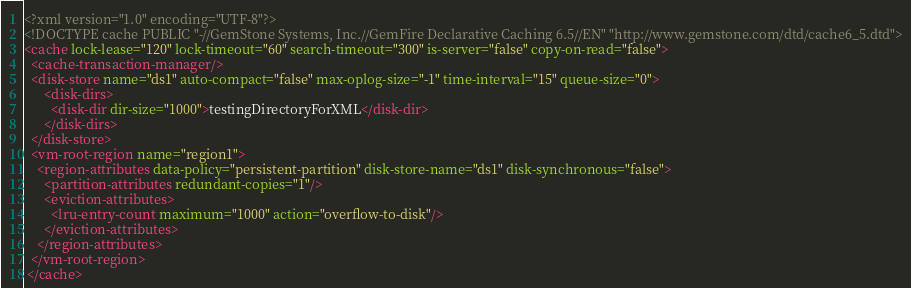Convert code to text. <code><loc_0><loc_0><loc_500><loc_500><_XML_><?xml version="1.0" encoding="UTF-8"?>
<!DOCTYPE cache PUBLIC "-//GemStone Systems, Inc.//GemFire Declarative Caching 6.5//EN" "http://www.gemstone.com/dtd/cache6_5.dtd">
<cache lock-lease="120" lock-timeout="60" search-timeout="300" is-server="false" copy-on-read="false">
  <cache-transaction-manager/>
  <disk-store name="ds1" auto-compact="false" max-oplog-size="-1" time-interval="15" queue-size="0">
      <disk-dirs>
        <disk-dir dir-size="1000">testingDirectoryForXML</disk-dir>
      </disk-dirs>
  </disk-store>
  <vm-root-region name="region1">
    <region-attributes data-policy="persistent-partition" disk-store-name="ds1" disk-synchronous="false">
      <partition-attributes redundant-copies="1"/>
      <eviction-attributes>
        <lru-entry-count maximum="1000" action="overflow-to-disk"/>
      </eviction-attributes>
    </region-attributes>
  </vm-root-region>
 </cache>
</code> 